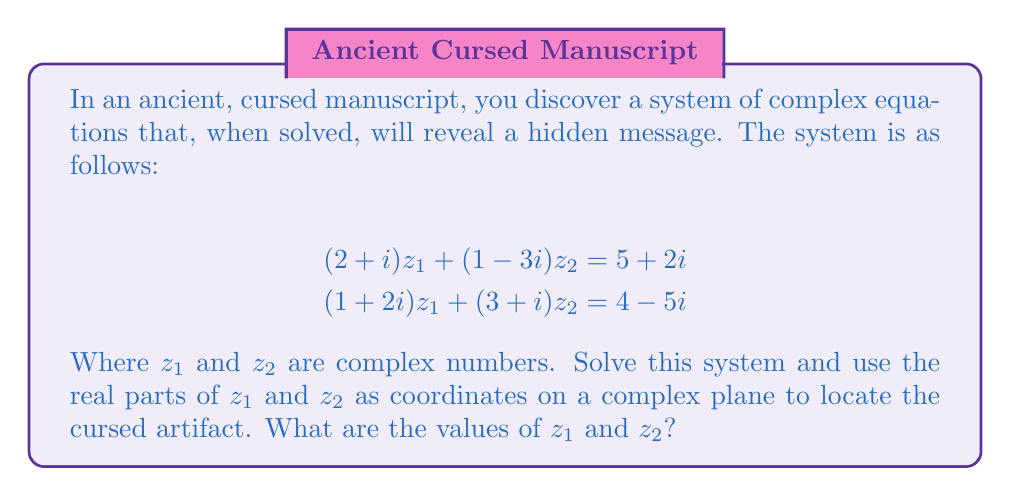Teach me how to tackle this problem. To solve this system of complex equations, we'll use the substitution method:

1) First, let's express $z_2$ in terms of $z_1$ from the first equation:

   $$(2+i)z_1 + (1-3i)z_2 = 5+2i$$
   $$(1-3i)z_2 = (5+2i) - (2+i)z_1$$
   $$z_2 = \frac{(5+2i) - (2+i)z_1}{1-3i}$$

2) Multiply both numerator and denominator by the complex conjugate of the denominator (1+3i):

   $$z_2 = \frac{((5+2i) - (2+i)z_1)(1+3i)}{(1-3i)(1+3i)} = \frac{((5+2i) - (2+i)z_1)(1+3i)}{10}$$

3) Expand this:

   $$z_2 = \frac{(5+2i)(1+3i) - (2+i)z_1(1+3i)}{10}$$
   $$z_2 = \frac{(5+15i+2i-6) - (2+i+6i+3i^2)z_1}{10}$$
   $$z_2 = \frac{(-1+17i) - (2+7i-3)z_1}{10}$$
   $$z_2 = \frac{-1+17i - 2z_1-7iz_1+3z_1}{10}$$
   $$z_2 = \frac{-1+17i + z_1-7iz_1}{10}$$

4) Substitute this expression for $z_2$ into the second equation:

   $$(1+2i)z_1 + (3+i)(\frac{-1+17i + z_1-7iz_1}{10}) = 4-5i$$

5) Multiply both sides by 10:

   $$10(1+2i)z_1 + (3+i)(-1+17i + z_1-7iz_1) = 40-50i$$

6) Expand:

   $$(10+20i)z_1 + (-3-i+51i+17i^2 + 3z_1+iz_1-21iz_1-7i^2z_1) = 40-50i$$
   $$(10+20i)z_1 + (-20+50i + 3z_1+iz_1-21iz_1+7z_1) = 40-50i$$

7) Collect terms:

   $$(20+20i)z_1 + (-20+50i) = 40-50i$$
   $$(20+20i)z_1 = 60-100i$$

8) Divide both sides by (20+20i), multiplying numerator and denominator by the complex conjugate:

   $$z_1 = \frac{(60-100i)(20-20i)}{(20+20i)(20-20i)} = \frac{1200-2000i+1200i+2000}{800} = \frac{3200-800i}{800} = 4-i$$

9) Substitute this value of $z_1$ back into the expression for $z_2$:

   $$z_2 = \frac{-1+17i + (4-i)-7i(4-i)}{10}$$
   $$z_2 = \frac{-1+17i + 4-i-28i+7i^2}{10}$$
   $$z_2 = \frac{-1+17i + 4-i-28i-7}{10}$$
   $$z_2 = \frac{-4-12i}{10} = -0.4-1.2i$$

Therefore, the solutions are $z_1 = 4-i$ and $z_2 = -0.4-1.2i$.
Answer: $z_1 = 4-i$ and $z_2 = -0.4-1.2i$ 